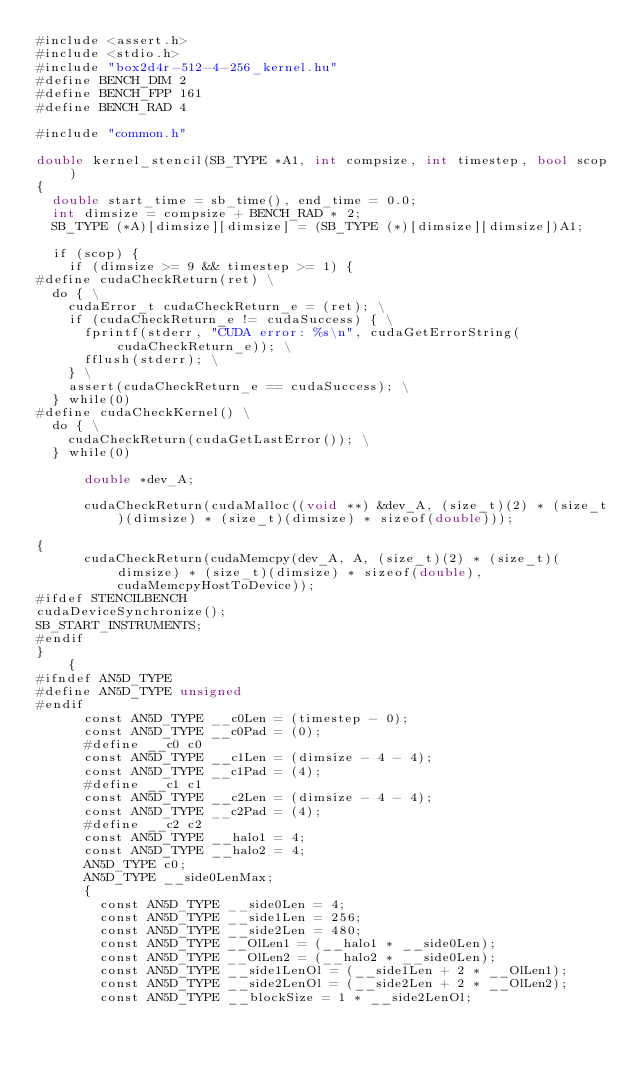<code> <loc_0><loc_0><loc_500><loc_500><_Cuda_>#include <assert.h>
#include <stdio.h>
#include "box2d4r-512-4-256_kernel.hu"
#define BENCH_DIM 2
#define BENCH_FPP 161
#define BENCH_RAD 4

#include "common.h"

double kernel_stencil(SB_TYPE *A1, int compsize, int timestep, bool scop)
{
  double start_time = sb_time(), end_time = 0.0;
  int dimsize = compsize + BENCH_RAD * 2;
  SB_TYPE (*A)[dimsize][dimsize] = (SB_TYPE (*)[dimsize][dimsize])A1;

  if (scop) {
    if (dimsize >= 9 && timestep >= 1) {
#define cudaCheckReturn(ret) \
  do { \
    cudaError_t cudaCheckReturn_e = (ret); \
    if (cudaCheckReturn_e != cudaSuccess) { \
      fprintf(stderr, "CUDA error: %s\n", cudaGetErrorString(cudaCheckReturn_e)); \
      fflush(stderr); \
    } \
    assert(cudaCheckReturn_e == cudaSuccess); \
  } while(0)
#define cudaCheckKernel() \
  do { \
    cudaCheckReturn(cudaGetLastError()); \
  } while(0)

      double *dev_A;
      
      cudaCheckReturn(cudaMalloc((void **) &dev_A, (size_t)(2) * (size_t)(dimsize) * (size_t)(dimsize) * sizeof(double)));
      
{
      cudaCheckReturn(cudaMemcpy(dev_A, A, (size_t)(2) * (size_t)(dimsize) * (size_t)(dimsize) * sizeof(double), cudaMemcpyHostToDevice));
#ifdef STENCILBENCH
cudaDeviceSynchronize();
SB_START_INSTRUMENTS;
#endif
}
    {
#ifndef AN5D_TYPE
#define AN5D_TYPE unsigned
#endif
      const AN5D_TYPE __c0Len = (timestep - 0);
      const AN5D_TYPE __c0Pad = (0);
      #define __c0 c0
      const AN5D_TYPE __c1Len = (dimsize - 4 - 4);
      const AN5D_TYPE __c1Pad = (4);
      #define __c1 c1
      const AN5D_TYPE __c2Len = (dimsize - 4 - 4);
      const AN5D_TYPE __c2Pad = (4);
      #define __c2 c2
      const AN5D_TYPE __halo1 = 4;
      const AN5D_TYPE __halo2 = 4;
      AN5D_TYPE c0;
      AN5D_TYPE __side0LenMax;
      {
        const AN5D_TYPE __side0Len = 4;
        const AN5D_TYPE __side1Len = 256;
        const AN5D_TYPE __side2Len = 480;
        const AN5D_TYPE __OlLen1 = (__halo1 * __side0Len);
        const AN5D_TYPE __OlLen2 = (__halo2 * __side0Len);
        const AN5D_TYPE __side1LenOl = (__side1Len + 2 * __OlLen1);
        const AN5D_TYPE __side2LenOl = (__side2Len + 2 * __OlLen2);
        const AN5D_TYPE __blockSize = 1 * __side2LenOl;</code> 